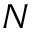Convert formula to latex. <formula><loc_0><loc_0><loc_500><loc_500>N</formula> 